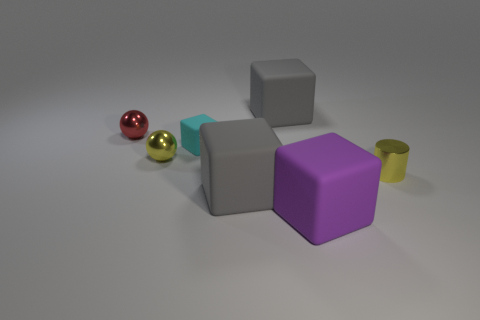What is the material of the large gray object that is in front of the small cylinder?
Offer a very short reply. Rubber. Do the red shiny sphere and the cyan matte thing have the same size?
Provide a succinct answer. Yes. How many matte objects are either yellow balls or blocks?
Provide a succinct answer. 4. What is the material of the cyan object that is the same size as the yellow ball?
Your answer should be very brief. Rubber. How many other objects are there of the same material as the cylinder?
Give a very brief answer. 2. Are there fewer large blocks that are behind the cyan thing than large cyan matte cylinders?
Your response must be concise. No. Is the shape of the large purple thing the same as the tiny rubber thing?
Offer a very short reply. Yes. There is a gray matte object behind the yellow thing right of the small ball in front of the small rubber object; what size is it?
Keep it short and to the point. Large. There is another thing that is the same shape as the red shiny thing; what is it made of?
Keep it short and to the point. Metal. Is there anything else that is the same size as the purple matte block?
Offer a very short reply. Yes. 